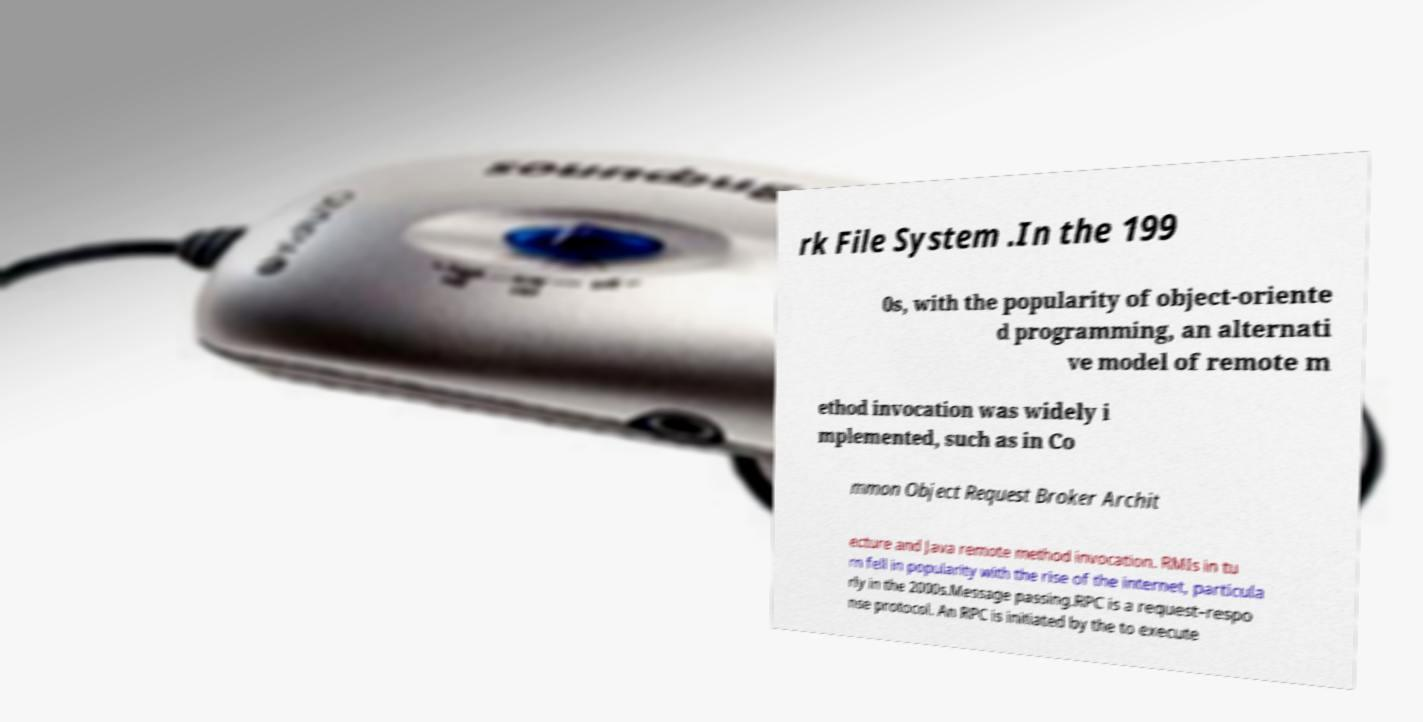There's text embedded in this image that I need extracted. Can you transcribe it verbatim? rk File System .In the 199 0s, with the popularity of object-oriente d programming, an alternati ve model of remote m ethod invocation was widely i mplemented, such as in Co mmon Object Request Broker Archit ecture and Java remote method invocation. RMIs in tu rn fell in popularity with the rise of the internet, particula rly in the 2000s.Message passing.RPC is a request–respo nse protocol. An RPC is initiated by the to execute 